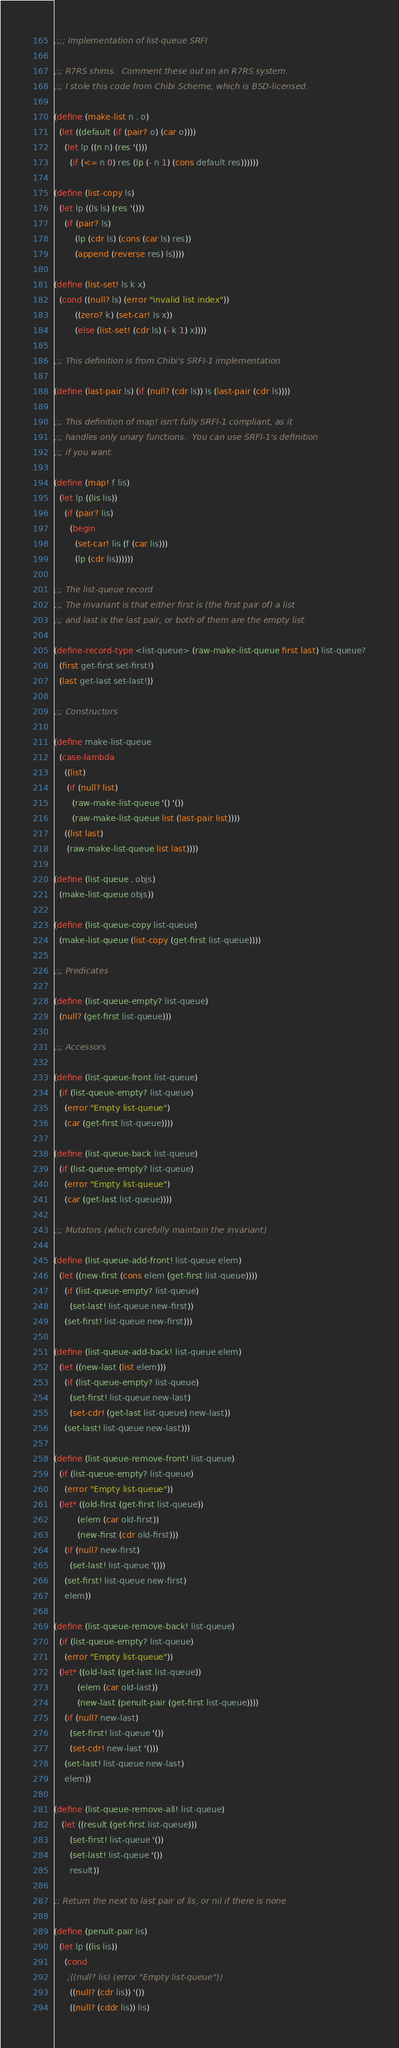Convert code to text. <code><loc_0><loc_0><loc_500><loc_500><_Scheme_>;;;; Implementation of list-queue SRFI

;;; R7RS shims.  Comment these out on an R7RS system.
;;; I stole this code from Chibi Scheme, which is BSD-licensed.

(define (make-list n . o)
  (let ((default (if (pair? o) (car o))))
    (let lp ((n n) (res '()))
      (if (<= n 0) res (lp (- n 1) (cons default res))))))

(define (list-copy ls)
  (let lp ((ls ls) (res '()))
    (if (pair? ls)
        (lp (cdr ls) (cons (car ls) res))
        (append (reverse res) ls))))

(define (list-set! ls k x)
  (cond ((null? ls) (error "invalid list index"))
        ((zero? k) (set-car! ls x))
        (else (list-set! (cdr ls) (- k 1) x))))

;;; This definition is from Chibi's SRFI-1 implementation.

(define (last-pair ls) (if (null? (cdr ls)) ls (last-pair (cdr ls))))

;;; This definition of map! isn't fully SRFI-1 compliant, as it
;;; handles only unary functions.  You can use SRFI-1's definition
;;; if you want.

(define (map! f lis)
  (let lp ((lis lis))
    (if (pair? lis)
      (begin
        (set-car! lis (f (car lis)))
        (lp (cdr lis))))))

;;; The list-queue record
;;; The invariant is that either first is (the first pair of) a list
;;; and last is the last pair, or both of them are the empty list.

(define-record-type <list-queue> (raw-make-list-queue first last) list-queue?
  (first get-first set-first!)
  (last get-last set-last!))

;;; Constructors

(define make-list-queue
  (case-lambda
    ((list)
     (if (null? list)
       (raw-make-list-queue '() '())
       (raw-make-list-queue list (last-pair list))))
    ((list last)
     (raw-make-list-queue list last))))

(define (list-queue . objs)
  (make-list-queue objs))

(define (list-queue-copy list-queue)
  (make-list-queue (list-copy (get-first list-queue))))

;;; Predicates

(define (list-queue-empty? list-queue)
  (null? (get-first list-queue)))

;;; Accessors

(define (list-queue-front list-queue)
  (if (list-queue-empty? list-queue)
    (error "Empty list-queue")
    (car (get-first list-queue))))

(define (list-queue-back list-queue)
  (if (list-queue-empty? list-queue)
    (error "Empty list-queue")
    (car (get-last list-queue))))

;;; Mutators (which carefully maintain the invariant)

(define (list-queue-add-front! list-queue elem)
  (let ((new-first (cons elem (get-first list-queue))))
    (if (list-queue-empty? list-queue)
      (set-last! list-queue new-first))
    (set-first! list-queue new-first)))

(define (list-queue-add-back! list-queue elem)
  (let ((new-last (list elem)))
    (if (list-queue-empty? list-queue)
      (set-first! list-queue new-last)
      (set-cdr! (get-last list-queue) new-last))
    (set-last! list-queue new-last)))

(define (list-queue-remove-front! list-queue)
  (if (list-queue-empty? list-queue)
    (error "Empty list-queue"))
  (let* ((old-first (get-first list-queue))
         (elem (car old-first))
         (new-first (cdr old-first)))
    (if (null? new-first)
      (set-last! list-queue '()))
    (set-first! list-queue new-first)
    elem))

(define (list-queue-remove-back! list-queue)
  (if (list-queue-empty? list-queue)
    (error "Empty list-queue"))
  (let* ((old-last (get-last list-queue))
         (elem (car old-last))
         (new-last (penult-pair (get-first list-queue))))
    (if (null? new-last)
      (set-first! list-queue '())
      (set-cdr! new-last '()))
    (set-last! list-queue new-last)
    elem))

(define (list-queue-remove-all! list-queue)
   (let ((result (get-first list-queue)))
      (set-first! list-queue '())
      (set-last! list-queue '())
      result))

;; Return the next to last pair of lis, or nil if there is none

(define (penult-pair lis)
  (let lp ((lis lis))
    (cond
     ;((null? lis) (error "Empty list-queue"))
      ((null? (cdr lis)) '())
      ((null? (cddr lis)) lis)</code> 